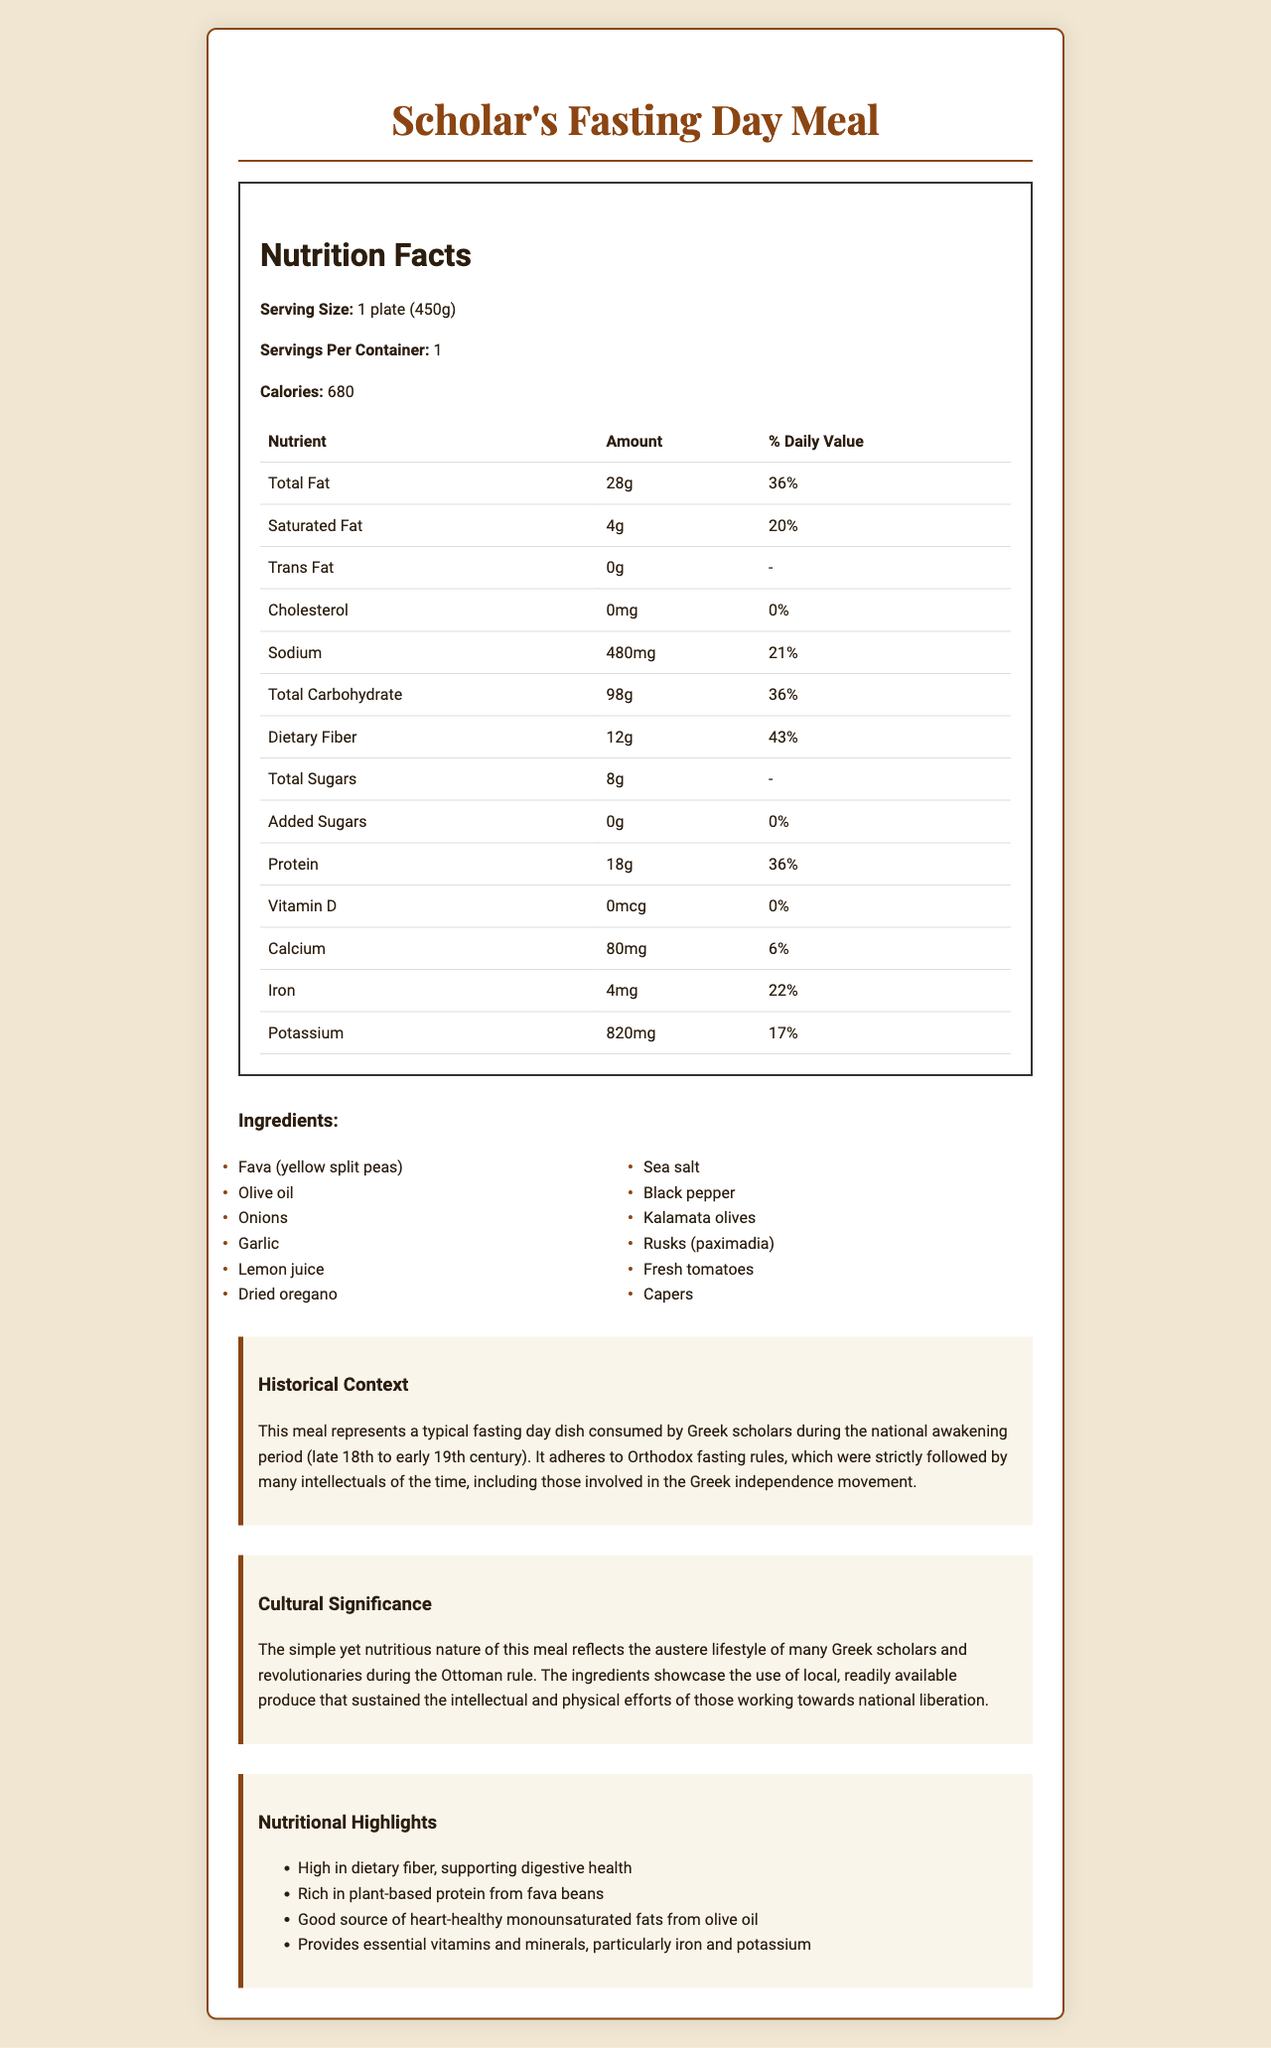what is the serving size of the meal? The serving size of the meal is stated as 1 plate, which is 450 grams.
Answer: 1 plate (450g) how many calories are there per serving? The document indicates that there are 680 calories per serving.
Answer: 680 calories how much dietary fiber does the meal contain? The amount of dietary fiber per serving is 12 grams.
Answer: 12g what is the percentage of daily value for protein? The document states that the protein content provides 36% of the daily value.
Answer: 36% name three ingredients used in the meal. These ingredients are listed among the ingredients used for the meal.
Answer: Fava (yellow split peas), Olive oil, Onions is there any cholesterol in the meal? The document indicates that the cholesterol amount is 0mg.
Answer: No what is the main source of protein in the meal? A. Chicken B. Fava (yellow split peas) C. Cheese Fava (yellow split peas) is listed as an ingredient and it is noted as rich in plant-based protein in the nutritional highlights.
Answer: B what percentage of the daily value for iron does this meal provide? A. 6% B. 17% C.  22% D. 36% The document states that the meal provides 22% of the daily value for iron.
Answer: C does the dish contain any added sugars? As per the document, added sugars amount to 0 grams.
Answer: No summarize the historical and cultural significance of this meal. The document explains the historical context and cultural significance by highlighting how the meal was part of the austere lifestyle led by Greek scholars and revolutionaries, adhering to Orthodox fasting rules and using local produce.
Answer: This meal reflects the austere lifestyle and the local, readily available produce used by Greek scholars during the Ottoman rule. It adheres to Orthodox fasting rules and provided essential nourishment for the intellectual efforts of those involved in the Greek independence movement. what is the daily value percentage of saturated fat in the meal? The document specifies that the meal contains 4g of saturated fat, which is 20% of the daily value.
Answer: 20% what is the total carbohydrate content in the meal? The total carbohydrate content of the meal is listed as 98 grams.
Answer: 98g name one of the nutritional highlights of the meal. This is one of the nutritional highlights mentioned in the document.
Answer: High in dietary fiber, supporting digestive health how much potassium does the meal contain? The document lists the potassium content as 820 milligrams.
Answer: 820mg what types of fats are present in the meal? The meal contains total fat (28g), saturated fat (4g), and trans fat (0g).
Answer: Total Fat, Saturated Fat, Trans Fat what is the amount of calcium in the meal? The document specifies that the meal contains 80 milligrams of calcium.
Answer: 80mg is this meal a good source of vitamin D? The document lists 0mcg of Vitamin D, indicating it is not a source of Vitamin D.
Answer: No what is the historical context of this meal? The document provides detailed historical context, emphasizing its adherence to fasting rules and consumption by scholars and intellectuals during a significant period in Greek history.
Answer: This meal represents a typical fasting day dish consumed by Greek scholars during the national awakening period (late 18th to early 19th century). It adheres to Orthodox fasting rules, which were strictly followed by many intellectuals of the time, including those involved in the Greek independence movement. what is the cultural significance of using local produce? The document links the use of local produce to the cultural significance of self-sustaining lifestyles during the Ottoman rule.
Answer: Using local produce showcases the self-sustaining and resourceful lifestyle of Greek scholars and revolutionaries during the Ottoman rule, ensuring they nourished both their intellectual and physical pursuits. how many grams of total sugars are in the meal? The document clearly states that the meal contains 8 grams of total sugars.
Answer: 8g what are rusks known as in Greek? The meal lists "Rusks (paximadia)" as one of the ingredients, indicating the Greek term for rusks.
Answer: Paximadia how does the meal adhere to Orthodox fasting rules? The document notes that the meal was consumed during fasting days and adheres to the Orthodox fasting rules followed by Greek scholars.
Answer: The meal consists of plant-based ingredients and contains no meat or dairy, which are restricted during Orthodox fasting periods. 